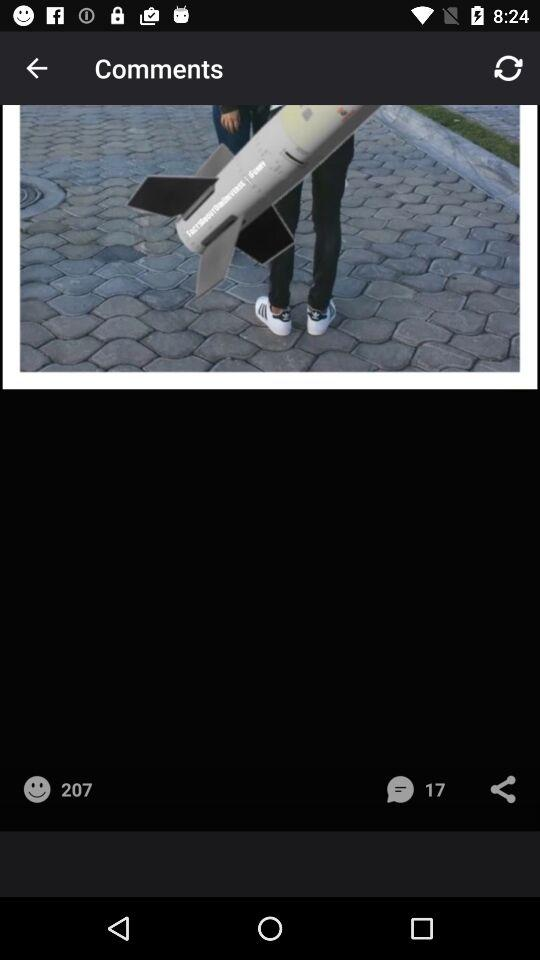How many comments are there? There are 17 comments. 